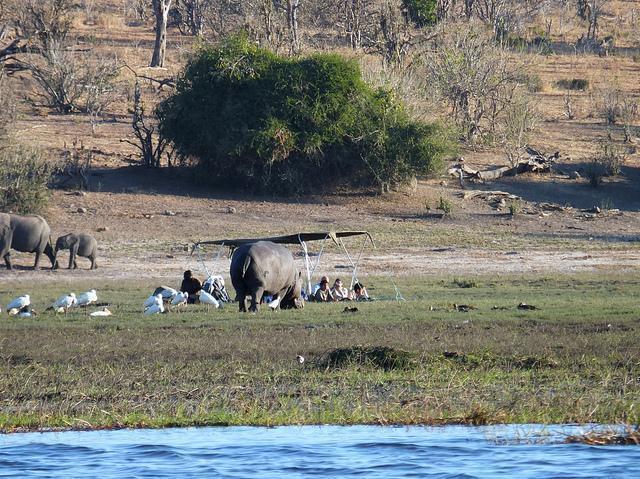Who are in the most danger?
From the following four choices, select the correct answer to address the question.
Options: Hippopotamus, humans, birds, elephants. Humans. 